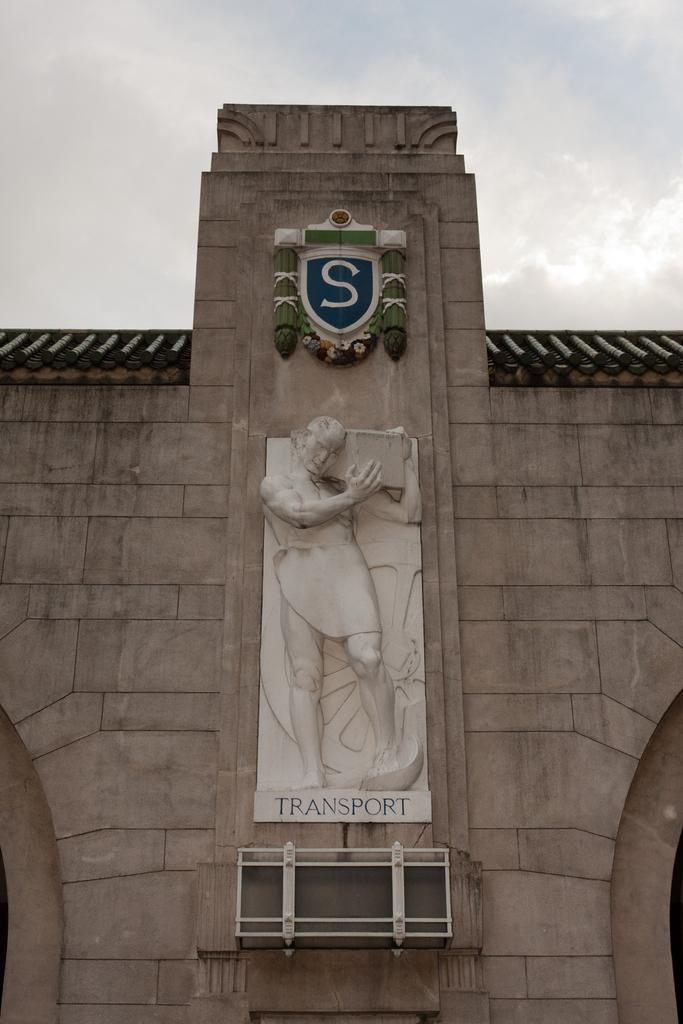<image>
Describe the image concisely. A large white statue on a building that says transport. 